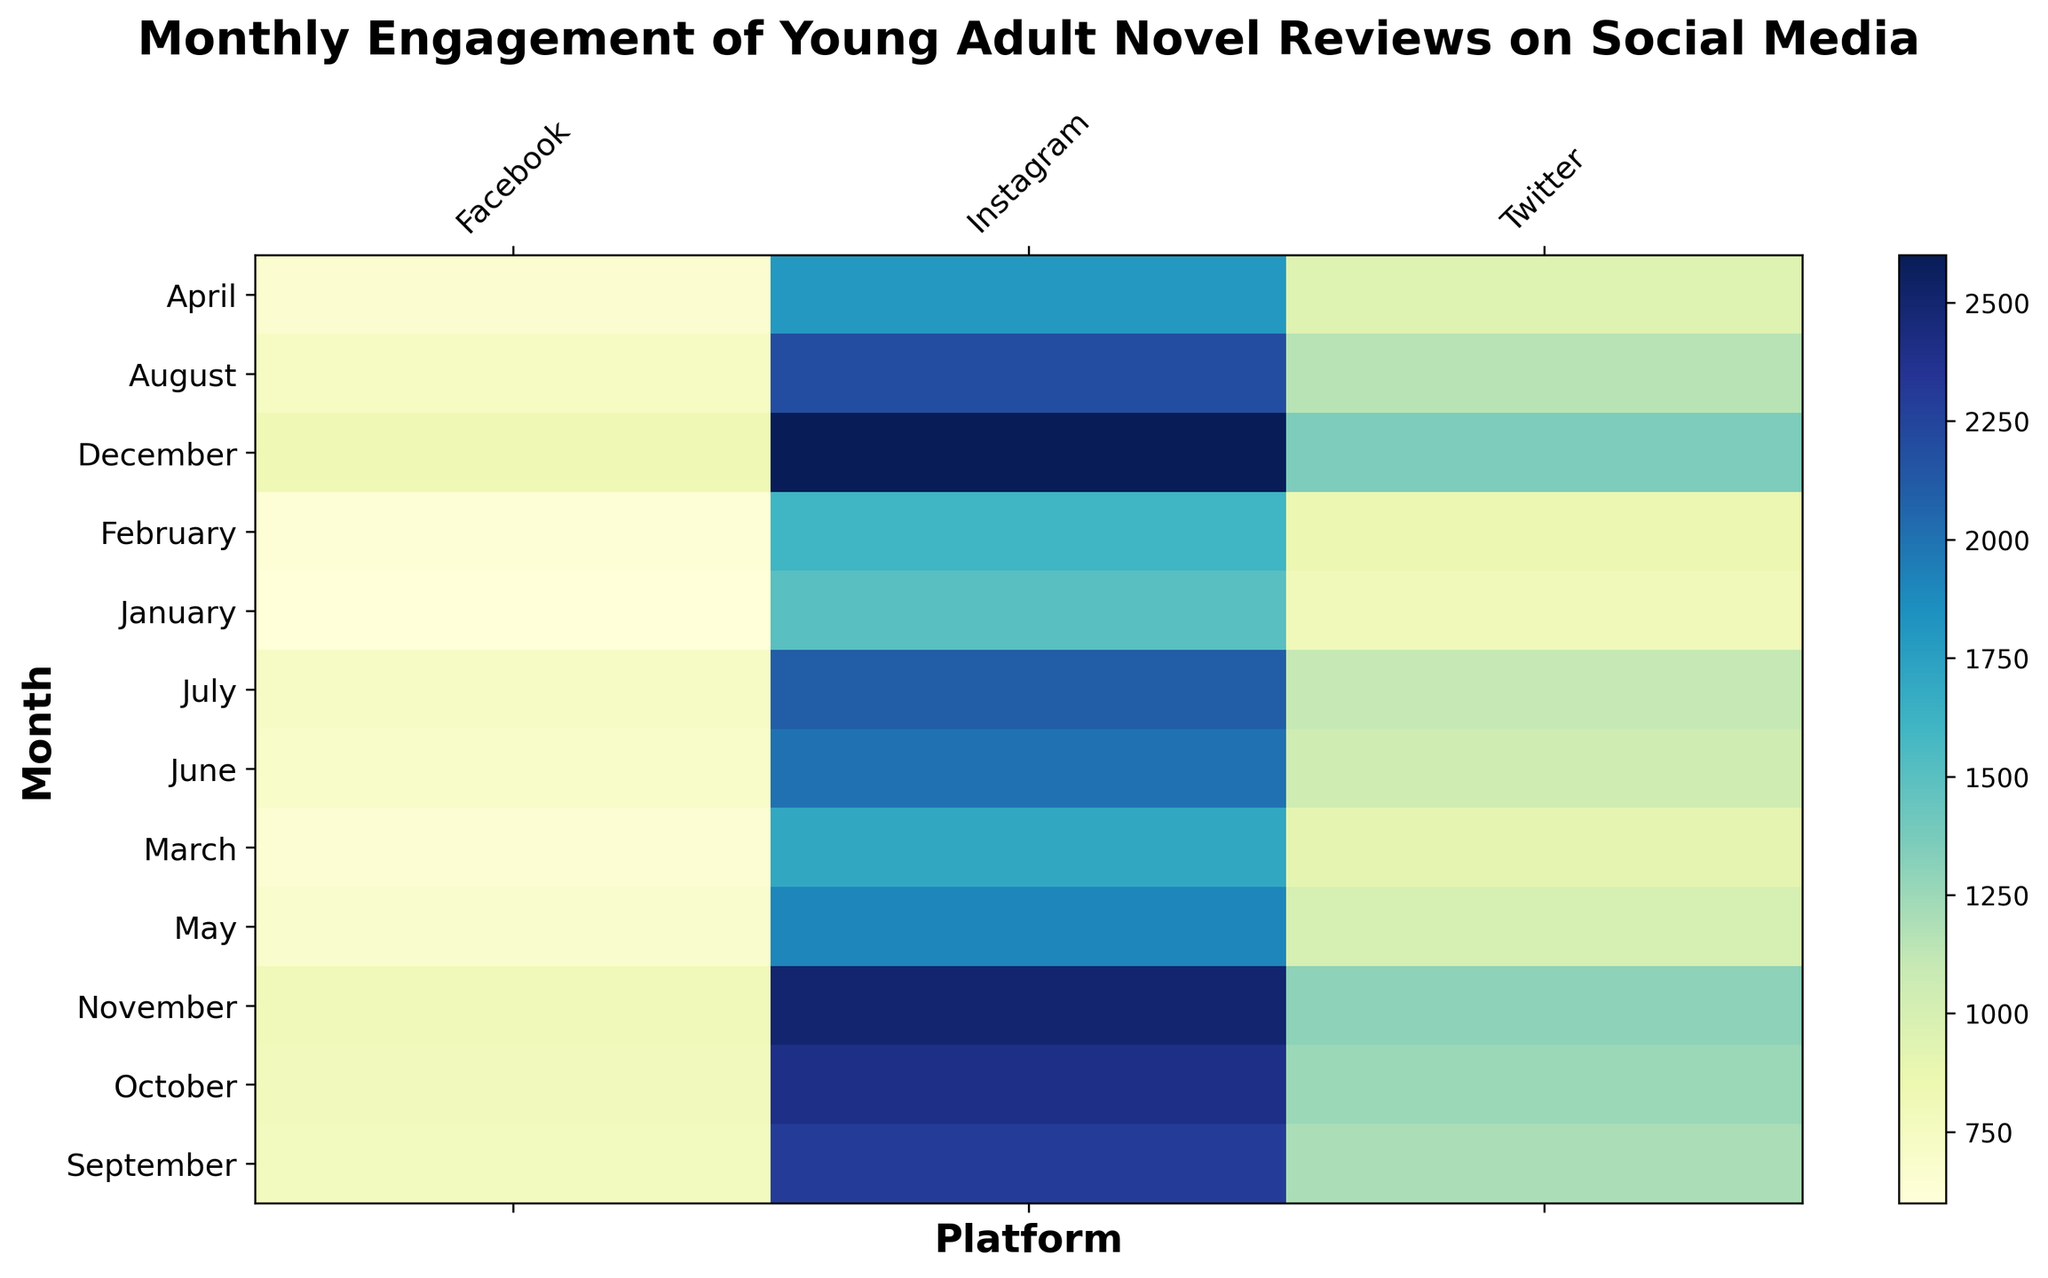What is the platform with the highest engagement in December? Look for the darkest shade on the heatmap under December month across all platforms. The darkest shade represents the highest engagement.
Answer: Instagram Which month sees the lowest engagement on Facebook? Identify the lightest color shade within the Facebook column. The lightest color indicates the lowest engagement.
Answer: January What is the average engagement for Instagram in the first quarter (January to March)? Sum the engagements for Instagram in January, February, and March, and then divide by 3. (1500 + 1600 + 1700) / 3 = 4800 / 3
Answer: 1600 Does Twitter's engagement in May exceed its engagement in March? Compare the color intensity for Twitter in May versus March. A darker shade in May indicates higher engagement compared to March.
Answer: Yes What is the difference in engagement between Twitter and Facebook in July? Subtract Facebook's engagement in July from Twitter's engagement in July. 1100 - 720 = 380
Answer: 380 Which month shows the least variation in engagement across all platforms? Look for the month where color shades are most similar across Instagram, Twitter, and Facebook. This suggests the least variation in engagement.
Answer: April How does the engagement in August on Instagram compare with the engagement in August on Facebook? Compare the color intensities of Instagram and Facebook in August. A darker shade on Instagram suggests higher engagement.
Answer: Higher engagement on Instagram What is the total engagement for Facebook in the second half of the year (July to December)? Sum the engagement values from July to December for Facebook. 720 + 740 + 760 + 780 + 800 + 820 = 4620
Answer: 4620 What is the ratio of engagement between Instagram and Twitter in October? Divide the engagement of Instagram by that of Twitter in October. 2400 / 1250 = 1.92
Answer: 1.92 Is there any month where the engagement on Twitter is exactly double compared to Facebook? Find any month where the color shade for Twitter is approximately twice as intense as for Facebook, suggesting double engagement.
Answer: No 